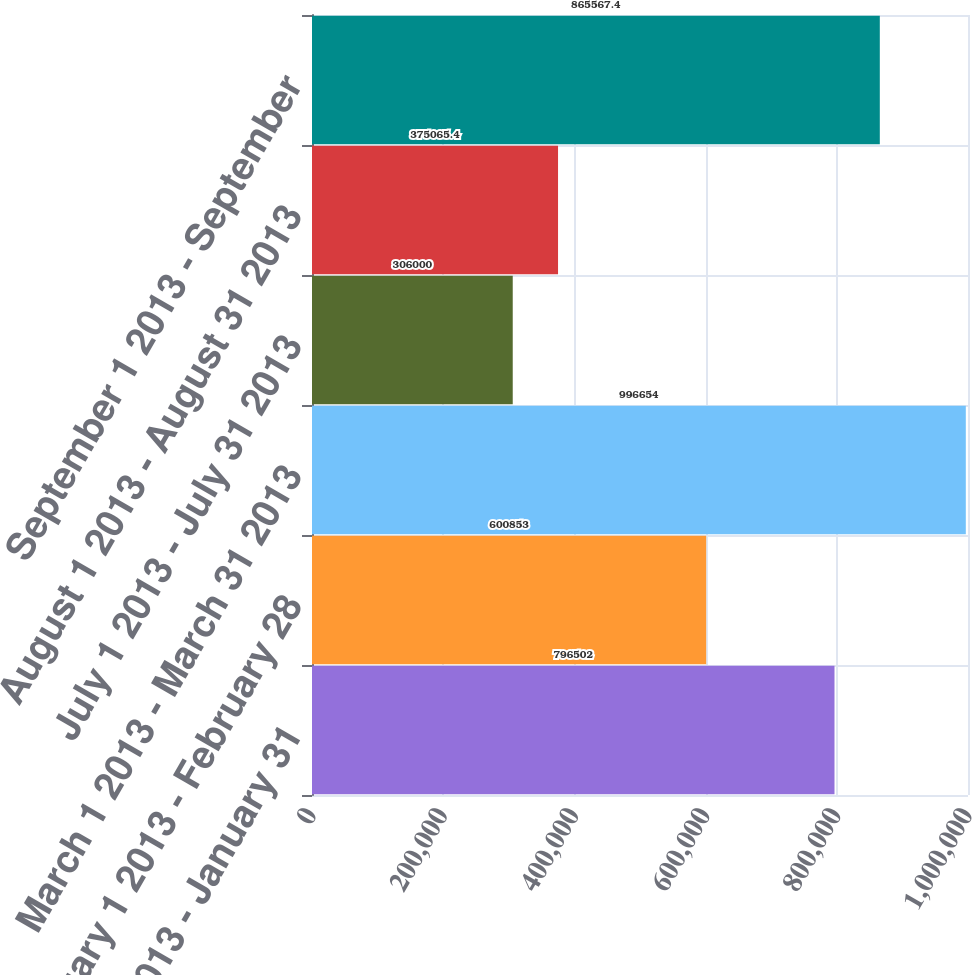Convert chart to OTSL. <chart><loc_0><loc_0><loc_500><loc_500><bar_chart><fcel>January 1 2013 - January 31<fcel>February 1 2013 - February 28<fcel>March 1 2013 - March 31 2013<fcel>July 1 2013 - July 31 2013<fcel>August 1 2013 - August 31 2013<fcel>September 1 2013 - September<nl><fcel>796502<fcel>600853<fcel>996654<fcel>306000<fcel>375065<fcel>865567<nl></chart> 